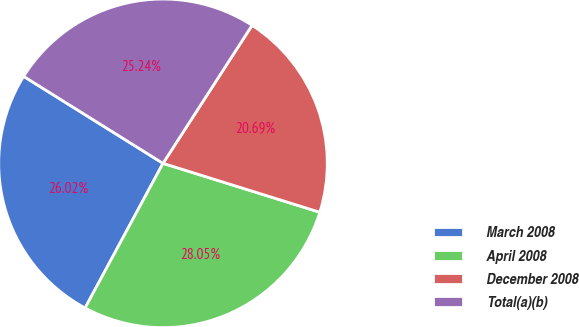Convert chart to OTSL. <chart><loc_0><loc_0><loc_500><loc_500><pie_chart><fcel>March 2008<fcel>April 2008<fcel>December 2008<fcel>Total(a)(b)<nl><fcel>26.02%<fcel>28.05%<fcel>20.69%<fcel>25.24%<nl></chart> 